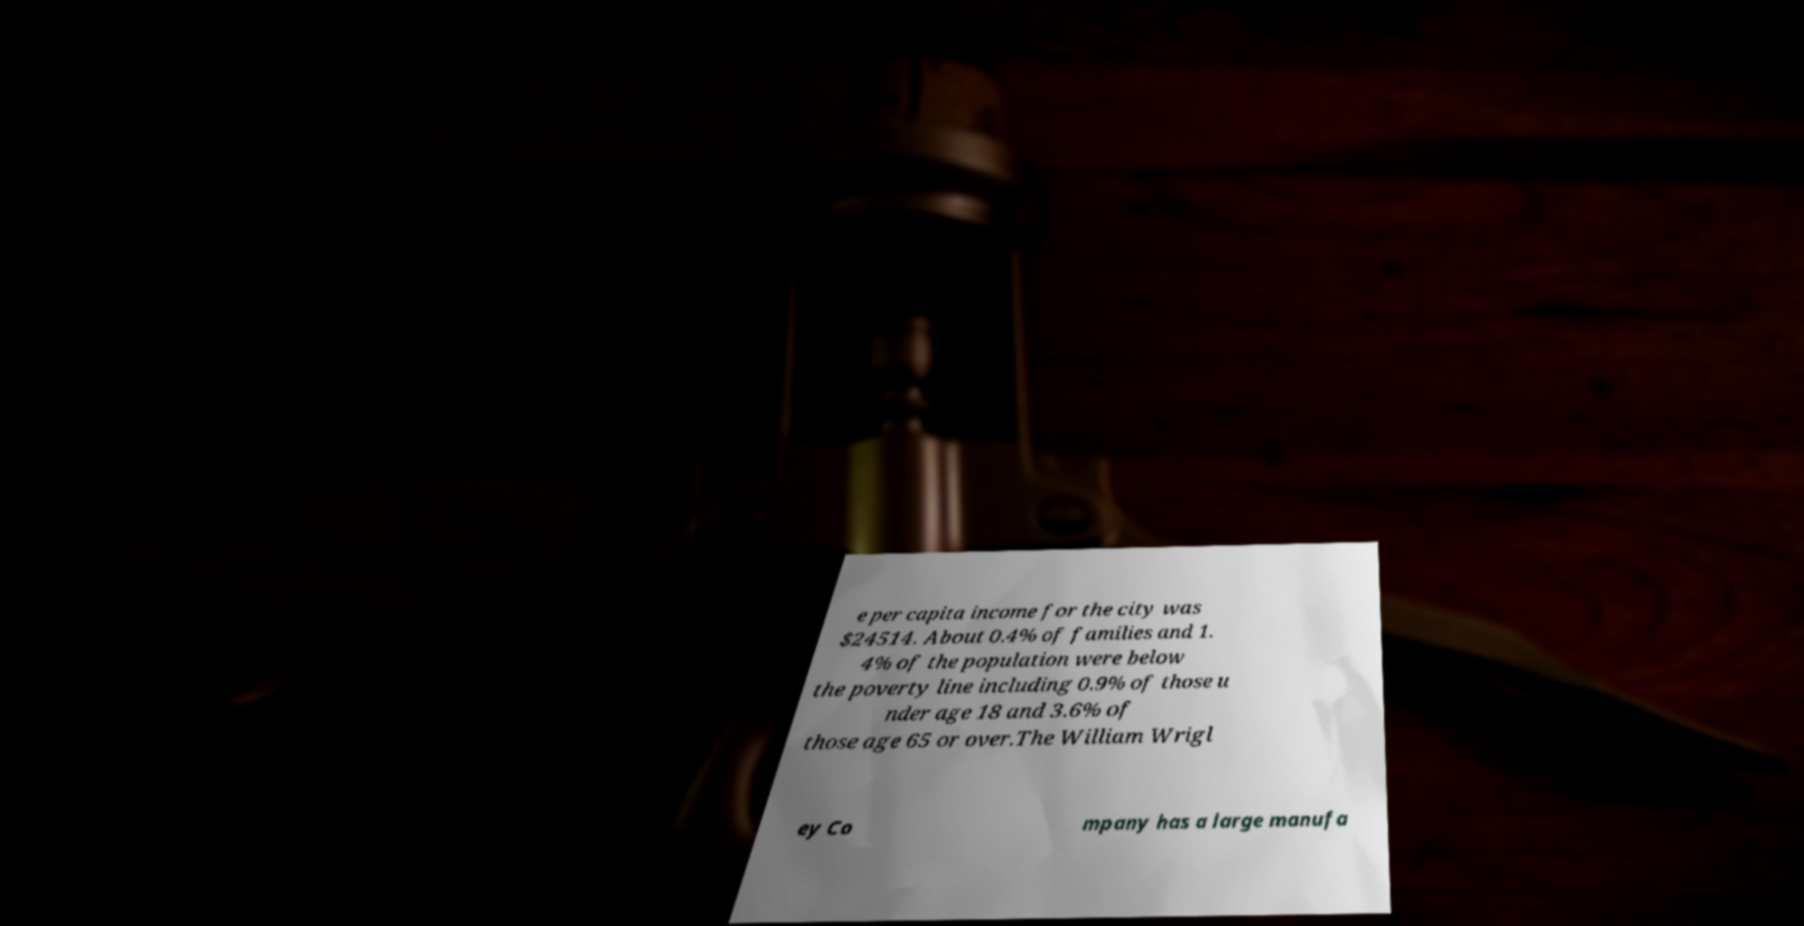What messages or text are displayed in this image? I need them in a readable, typed format. e per capita income for the city was $24514. About 0.4% of families and 1. 4% of the population were below the poverty line including 0.9% of those u nder age 18 and 3.6% of those age 65 or over.The William Wrigl ey Co mpany has a large manufa 